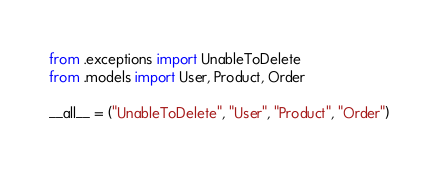<code> <loc_0><loc_0><loc_500><loc_500><_Python_>from .exceptions import UnableToDelete
from .models import User, Product, Order

__all__ = ("UnableToDelete", "User", "Product", "Order")
</code> 